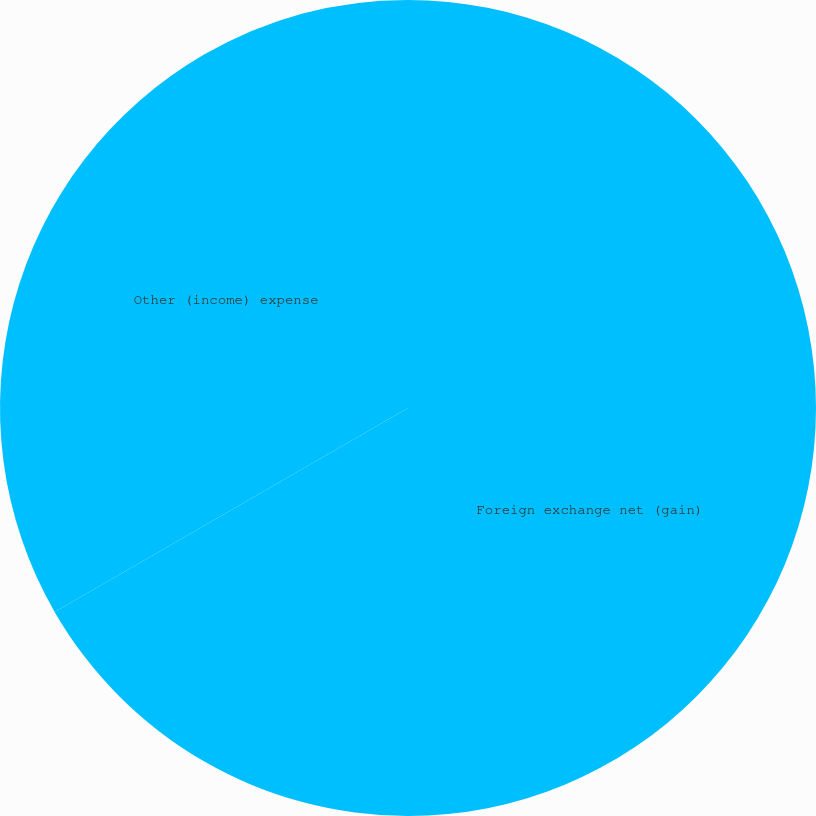Convert chart. <chart><loc_0><loc_0><loc_500><loc_500><pie_chart><fcel>Foreign exchange net (gain)<fcel>Other (income) expense<nl><fcel>66.67%<fcel>33.33%<nl></chart> 